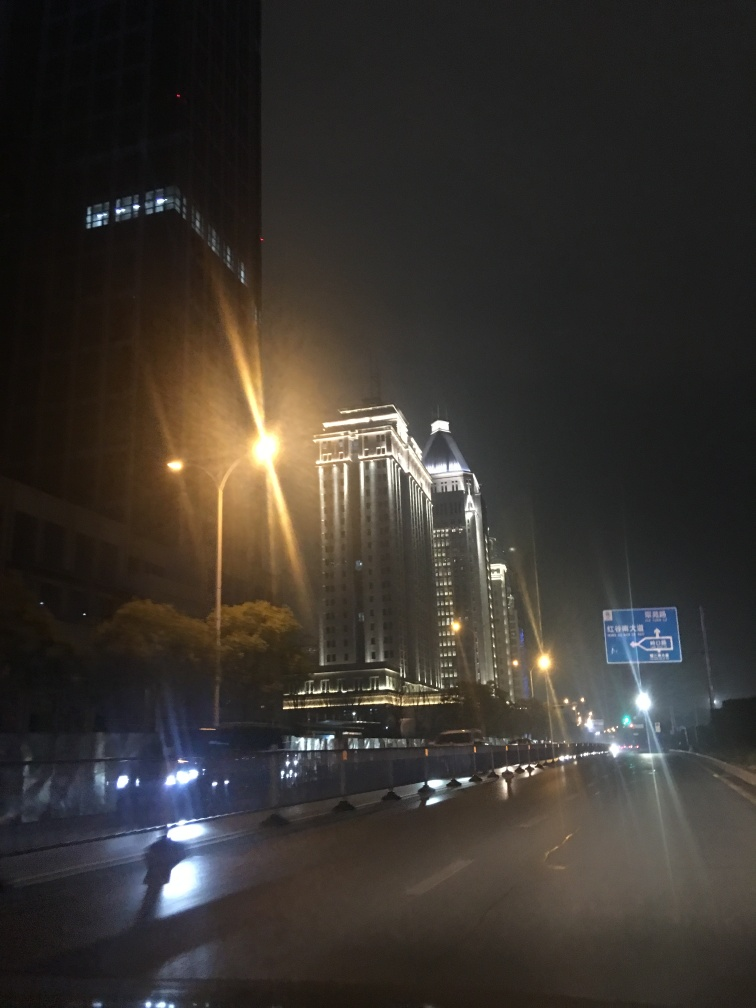Describe the mood of the city as shown in the image. The city exudes a tranquil and serene atmosphere, as seen by the absence of heavy traffic and the soft glow of the streetlights casting light on the buildings' facades. It gives a sense of quiet urbanity, with the darkness of the night contrasting with the pockets of light that define the architectural contours. 